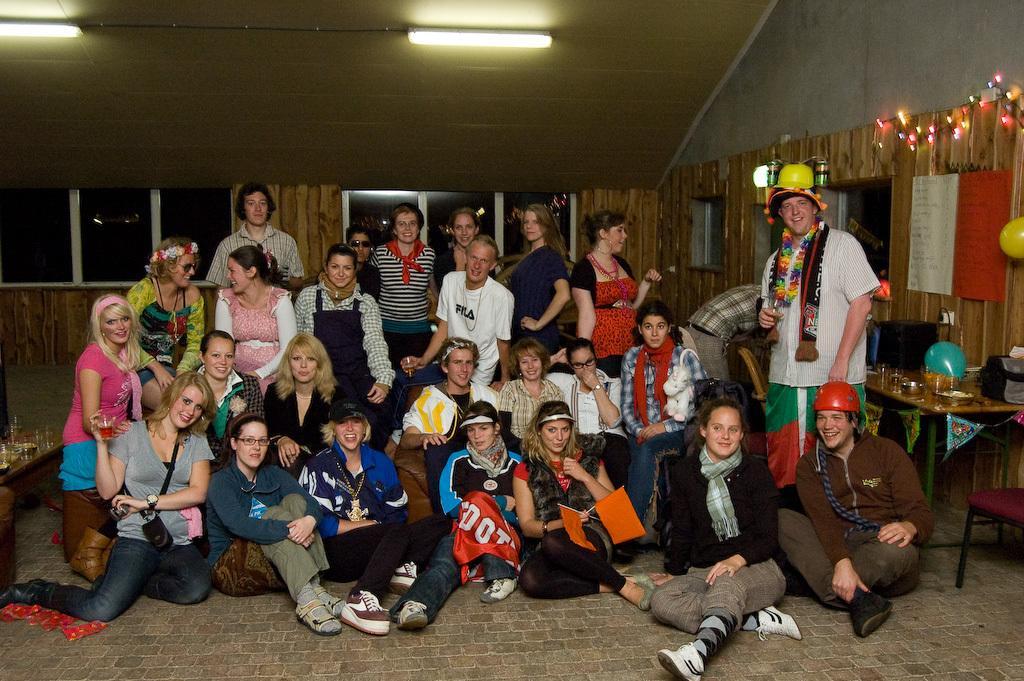Could you give a brief overview of what you see in this image? In this picture there are group of people in the center of the image and there are tables on the right and left side of the image, there are windows in the background area of the image. 